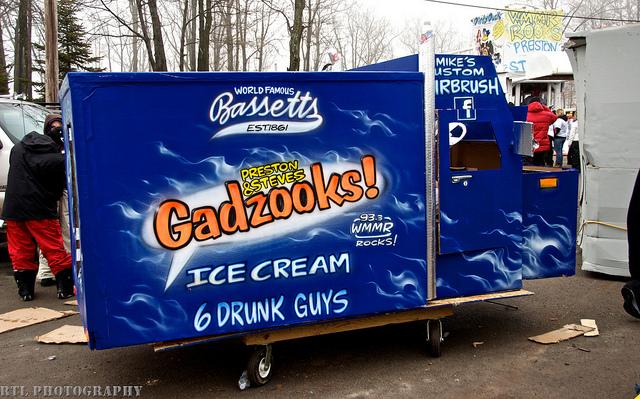Does the sentence at the bottom say "6 sober guys"?
Quick response, please. No. Would you want these people babysitting your children?
Be succinct. No. What does this stand off to eat?
Short answer required. Ice cream. For which radio station are the call letters written below the name of the ice cream?
Quick response, please. Wmmr. 